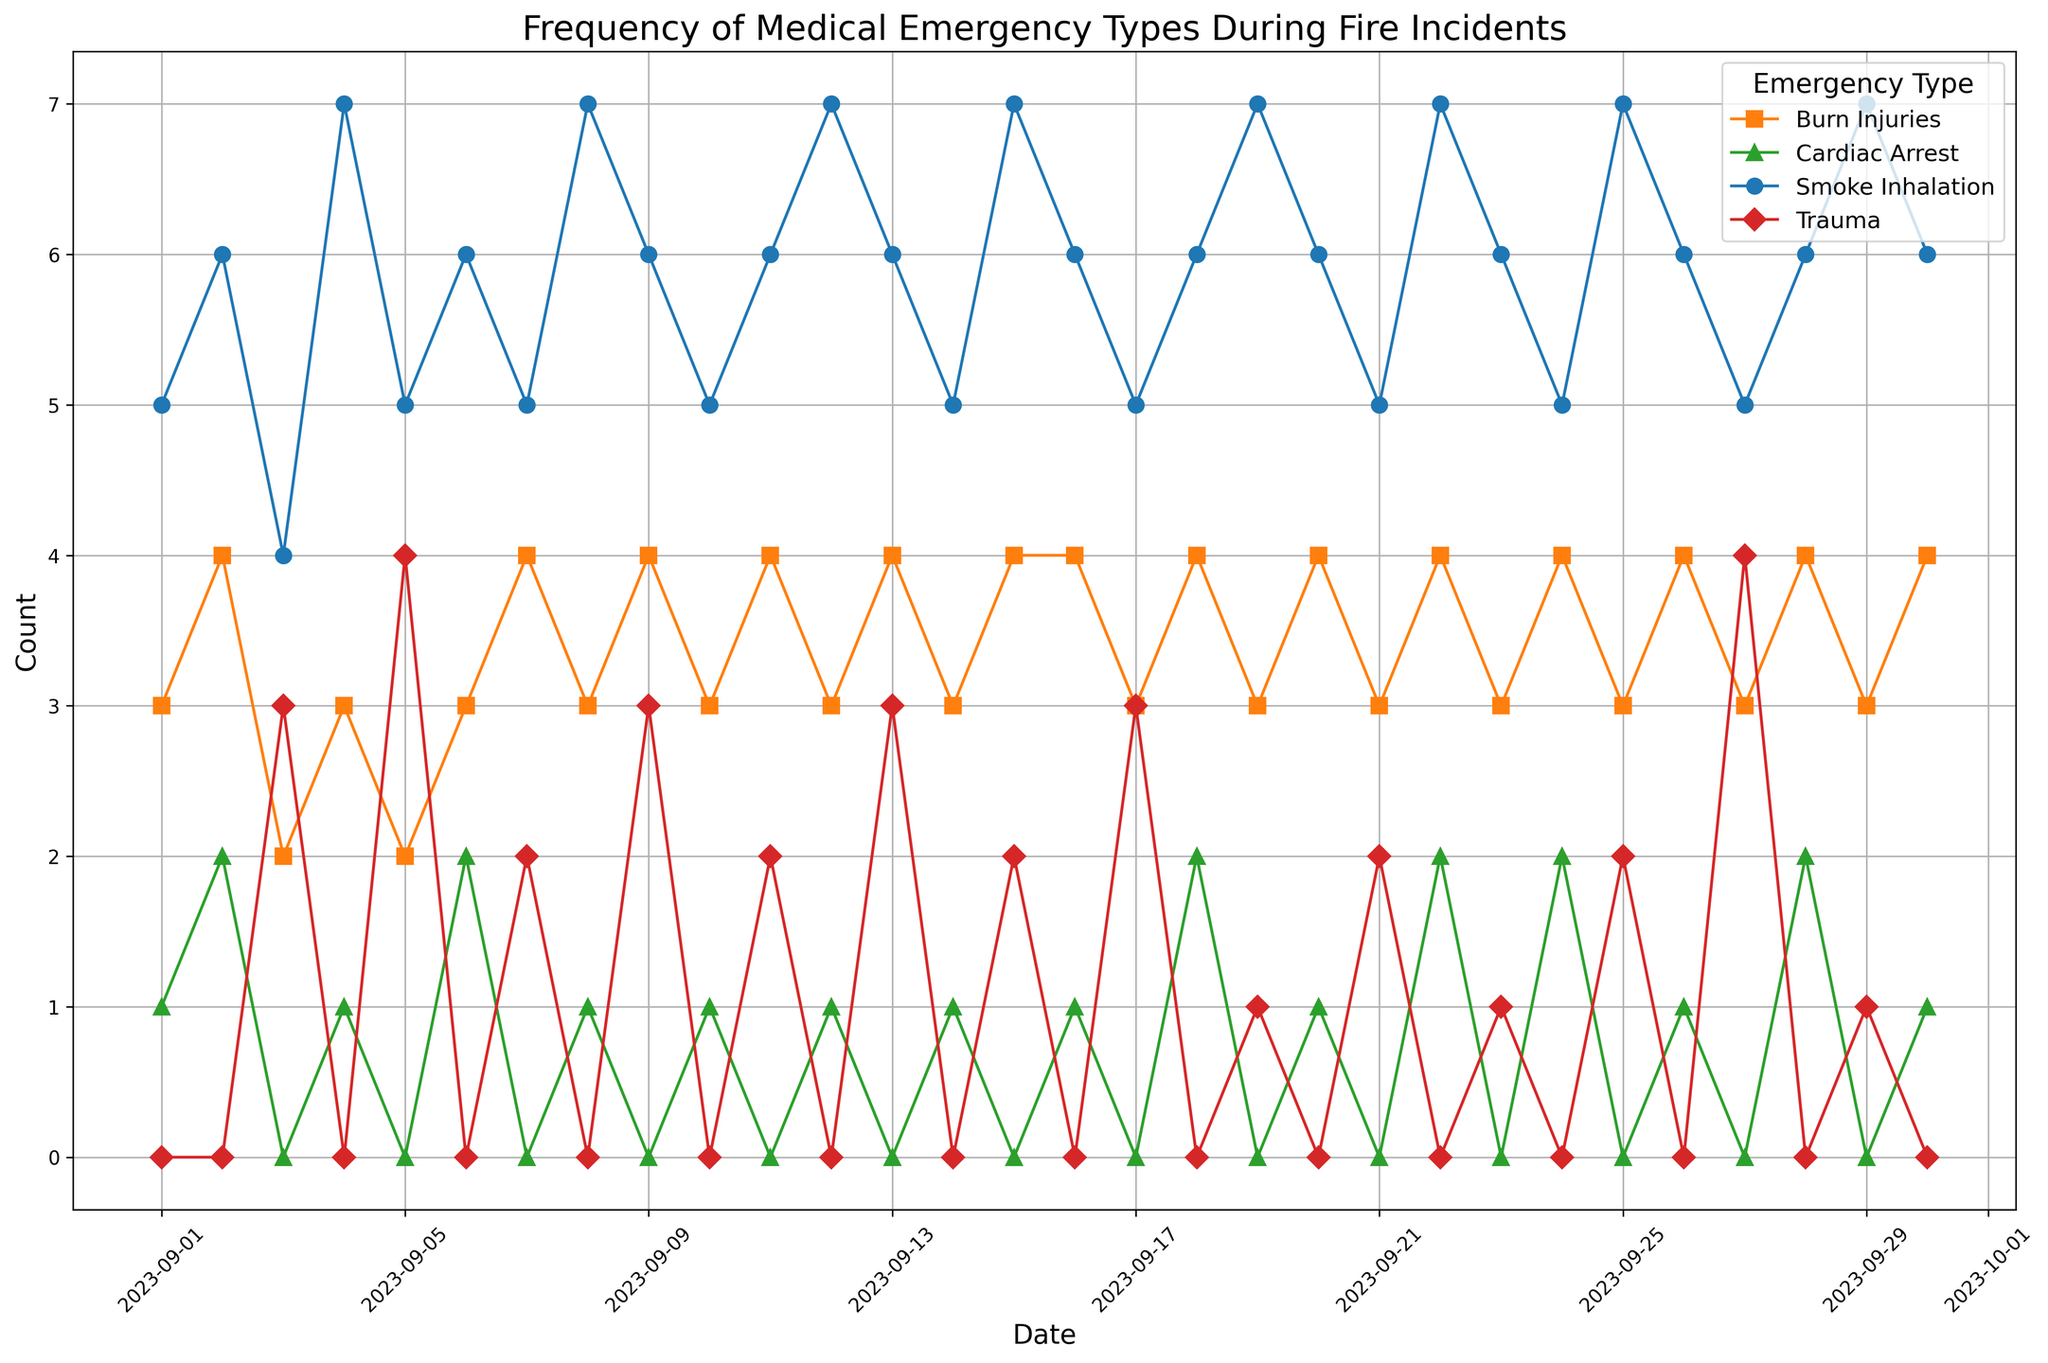What type of medical emergency had the highest frequency on September 1st? On September 1st, the figure shows distinct markers for each type of medical emergency. The 'Smoke Inhalation' entry has the tallest marker on that date.
Answer: Smoke Inhalation Between 'Smoke Inhalation' and 'Burn Injuries,' which had a consistent count of 6 occurrences over multiple dates? The figure shows lines with markers representing the counts for each date. 'Smoke Inhalation' consistently reaches 6 occurrences on several dates (e.g., September 2, 6, 11, 16). 'Burn Injuries' does not consistently have a count of 6 on any dates.
Answer: Smoke Inhalation What was the total number of 'Cardiac Arrest' incidents during the month? The figure's titles and labels help us identify the 'Cardiac Arrest' markers. Summing these counts (1+2+1+1+2+1+1+2+2+1+1+2+2+1+1+1 = 22) gives the total for the month.
Answer: 22 Which medical emergency had the fewest occurrences in a single day, and on which date? By examining the heights of the markers, 'Cardiac Arrest' had the fewest occurrences (with a marker height of 1) on multiple dates, such as September 1, 4, 8, 10, 12, etc.
Answer: Cardiac Arrest, multiple dates On September 10th, were 'Burn Injuries' incidents more or less than 'Trauma' incidents? Observing the markers for September 10th, 'Burn Injuries' had a count of 3, whereas 'Trauma' had no recorded incidents (no marker present).
Answer: More What is the overall trend of 'Smoke Inhalation' incidents throughout the month? Viewing the plot lines for 'Smoke Inhalation,' the data points and their markers do not show a significantly increasing or decreasing trend; they fluctuate between counts of 5, 6, and 7 throughout the month.
Answer: Fluctuating Is there any day when all four medical emergency types were encountered? The complete presence of four different markers on the same date indicates this. On September 3 and 9, all four types (Smoke Inhalation, Burn Injuries, Cardiac Arrest, Trauma) were encountered.
Answer: Yes, September 3 and 9 